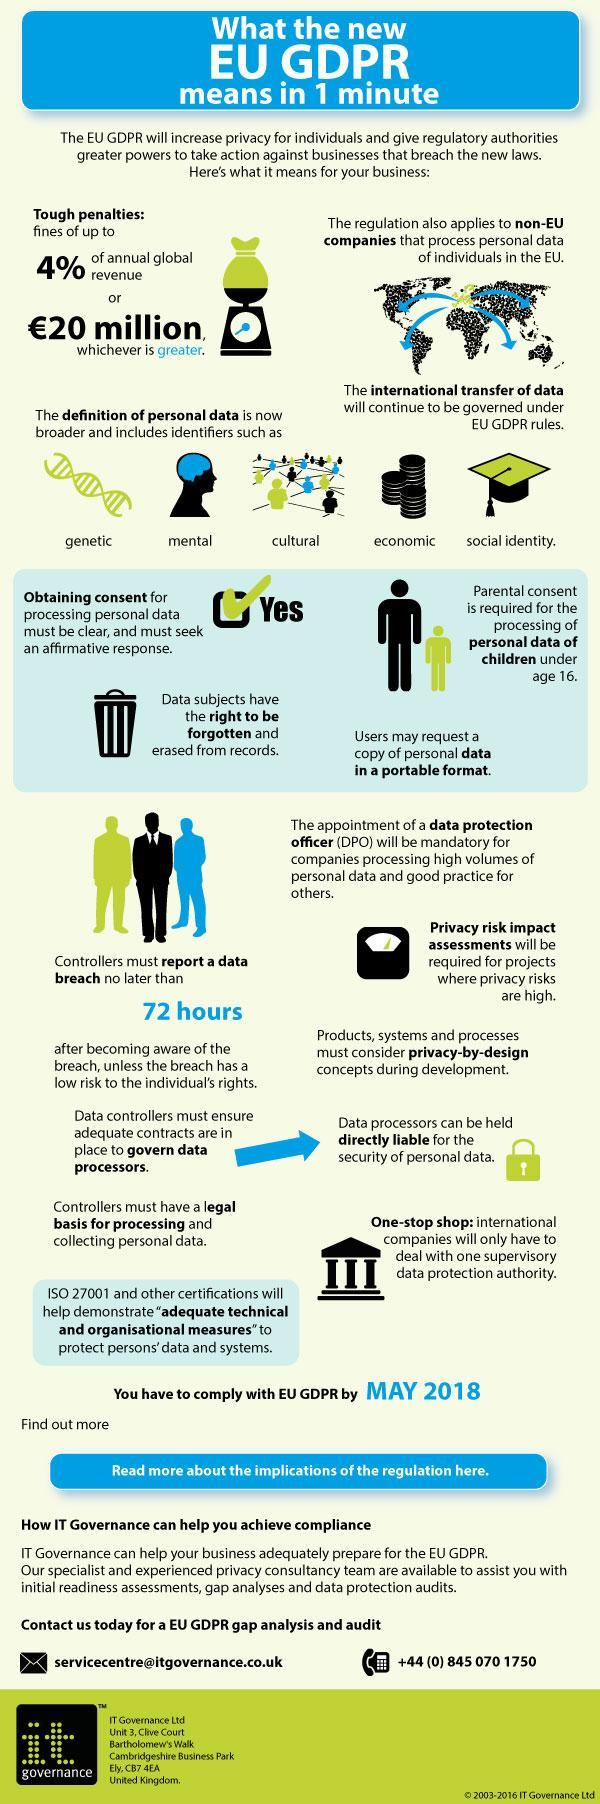Which is the fourth type of personal data as given in the infographic?
Answer the question with a short phrase. economic Wich consent is mandatory for dealing with privacy data of children below 16? Parental consent Which is the second type of personal data as given in the infographic? mental Whom should be appointed in company as mandatory, when the company handle with huge volume of personal data? data protection officer 